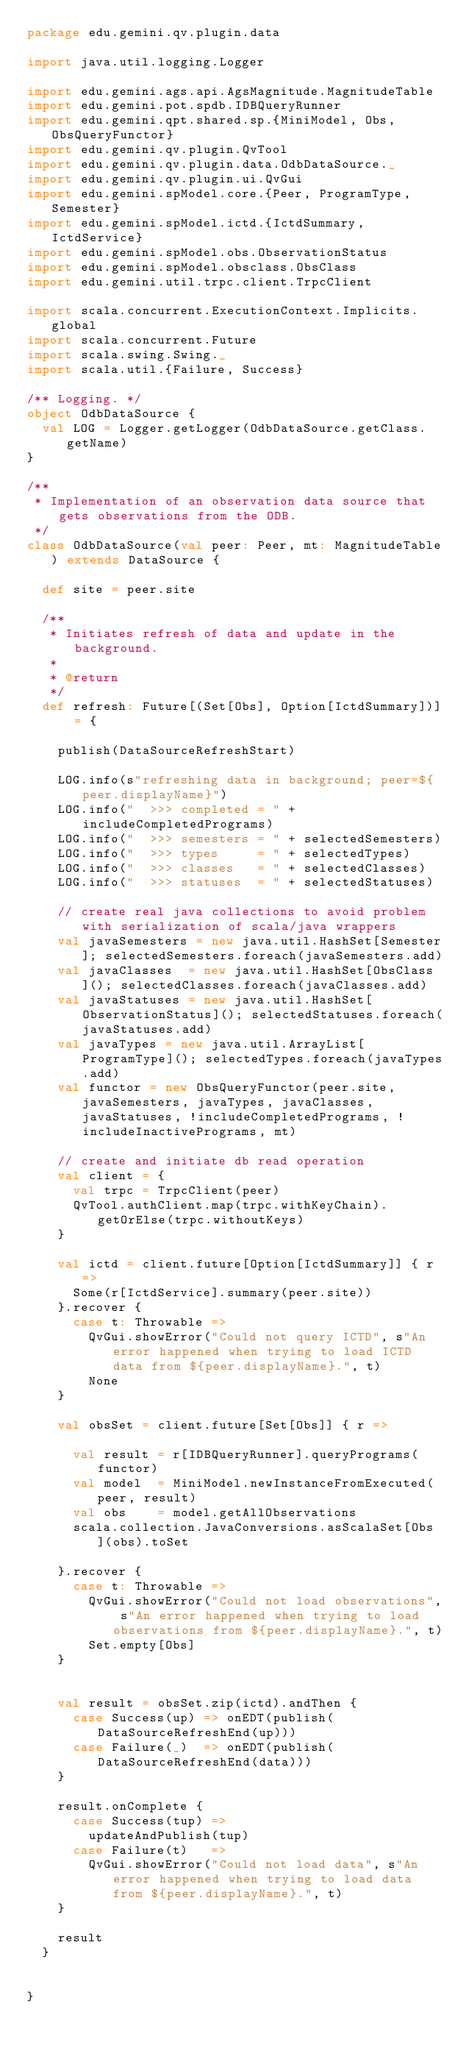<code> <loc_0><loc_0><loc_500><loc_500><_Scala_>package edu.gemini.qv.plugin.data

import java.util.logging.Logger

import edu.gemini.ags.api.AgsMagnitude.MagnitudeTable
import edu.gemini.pot.spdb.IDBQueryRunner
import edu.gemini.qpt.shared.sp.{MiniModel, Obs, ObsQueryFunctor}
import edu.gemini.qv.plugin.QvTool
import edu.gemini.qv.plugin.data.OdbDataSource._
import edu.gemini.qv.plugin.ui.QvGui
import edu.gemini.spModel.core.{Peer, ProgramType, Semester}
import edu.gemini.spModel.ictd.{IctdSummary, IctdService}
import edu.gemini.spModel.obs.ObservationStatus
import edu.gemini.spModel.obsclass.ObsClass
import edu.gemini.util.trpc.client.TrpcClient

import scala.concurrent.ExecutionContext.Implicits.global
import scala.concurrent.Future
import scala.swing.Swing._
import scala.util.{Failure, Success}

/** Logging. */
object OdbDataSource {
  val LOG = Logger.getLogger(OdbDataSource.getClass.getName)
}

/**
 * Implementation of an observation data source that gets observations from the ODB.
 */
class OdbDataSource(val peer: Peer, mt: MagnitudeTable) extends DataSource {

  def site = peer.site

  /**
   * Initiates refresh of data and update in the background.
   *
   * @return
   */
  def refresh: Future[(Set[Obs], Option[IctdSummary])] = {

    publish(DataSourceRefreshStart)

    LOG.info(s"refreshing data in background; peer=${peer.displayName}")
    LOG.info("  >>> completed = " + includeCompletedPrograms)
    LOG.info("  >>> semesters = " + selectedSemesters)
    LOG.info("  >>> types     = " + selectedTypes)
    LOG.info("  >>> classes   = " + selectedClasses)
    LOG.info("  >>> statuses  = " + selectedStatuses)

    // create real java collections to avoid problem with serialization of scala/java wrappers
    val javaSemesters = new java.util.HashSet[Semester]; selectedSemesters.foreach(javaSemesters.add)
    val javaClasses  = new java.util.HashSet[ObsClass](); selectedClasses.foreach(javaClasses.add)
    val javaStatuses = new java.util.HashSet[ObservationStatus](); selectedStatuses.foreach(javaStatuses.add)
    val javaTypes = new java.util.ArrayList[ProgramType](); selectedTypes.foreach(javaTypes.add)
    val functor = new ObsQueryFunctor(peer.site, javaSemesters, javaTypes, javaClasses, javaStatuses, !includeCompletedPrograms, !includeInactivePrograms, mt)

    // create and initiate db read operation
    val client = {
      val trpc = TrpcClient(peer)
      QvTool.authClient.map(trpc.withKeyChain).getOrElse(trpc.withoutKeys)
    }

    val ictd = client.future[Option[IctdSummary]] { r =>
      Some(r[IctdService].summary(peer.site))
    }.recover {
      case t: Throwable =>
        QvGui.showError("Could not query ICTD", s"An error happened when trying to load ICTD data from ${peer.displayName}.", t)
        None
    }

    val obsSet = client.future[Set[Obs]] { r =>

      val result = r[IDBQueryRunner].queryPrograms(functor)
      val model  = MiniModel.newInstanceFromExecuted(peer, result)
      val obs    = model.getAllObservations
      scala.collection.JavaConversions.asScalaSet[Obs](obs).toSet

    }.recover {
      case t: Throwable =>
        QvGui.showError("Could not load observations", s"An error happened when trying to load observations from ${peer.displayName}.", t)
        Set.empty[Obs]
    }


    val result = obsSet.zip(ictd).andThen {
      case Success(up) => onEDT(publish(DataSourceRefreshEnd(up)))
      case Failure(_)  => onEDT(publish(DataSourceRefreshEnd(data)))
    }

    result.onComplete {
      case Success(tup) =>
        updateAndPublish(tup)
      case Failure(t)   =>
        QvGui.showError("Could not load data", s"An error happened when trying to load data from ${peer.displayName}.", t)
    }

    result
  }


}
</code> 